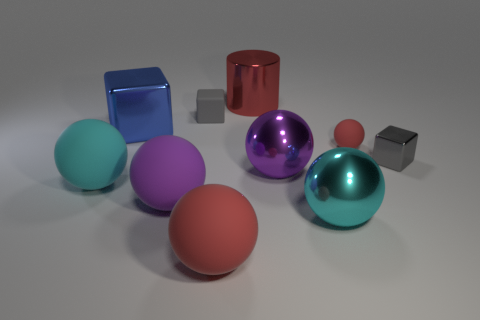Subtract 1 spheres. How many spheres are left? 5 Subtract all gray blocks. How many blocks are left? 1 Subtract 0 cyan cylinders. How many objects are left? 10 Subtract all blocks. How many objects are left? 7 Subtract all gray cubes. Subtract all brown cylinders. How many cubes are left? 1 Subtract all green blocks. How many purple balls are left? 2 Subtract all tiny balls. Subtract all big red rubber balls. How many objects are left? 8 Add 4 large matte balls. How many large matte balls are left? 7 Add 1 small green shiny cylinders. How many small green shiny cylinders exist? 1 Subtract all large red rubber spheres. How many spheres are left? 5 